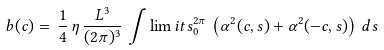<formula> <loc_0><loc_0><loc_500><loc_500>b ( c ) = \, \frac { 1 } { 4 } \, \eta \, \frac { L ^ { 3 } } { ( 2 \pi ) ^ { 3 } } \, \int \lim i t s _ { 0 } ^ { 2 \pi } \, \left ( \alpha ^ { 2 } ( c , s ) + \alpha ^ { 2 } ( - c , s ) \right ) \, d s</formula> 